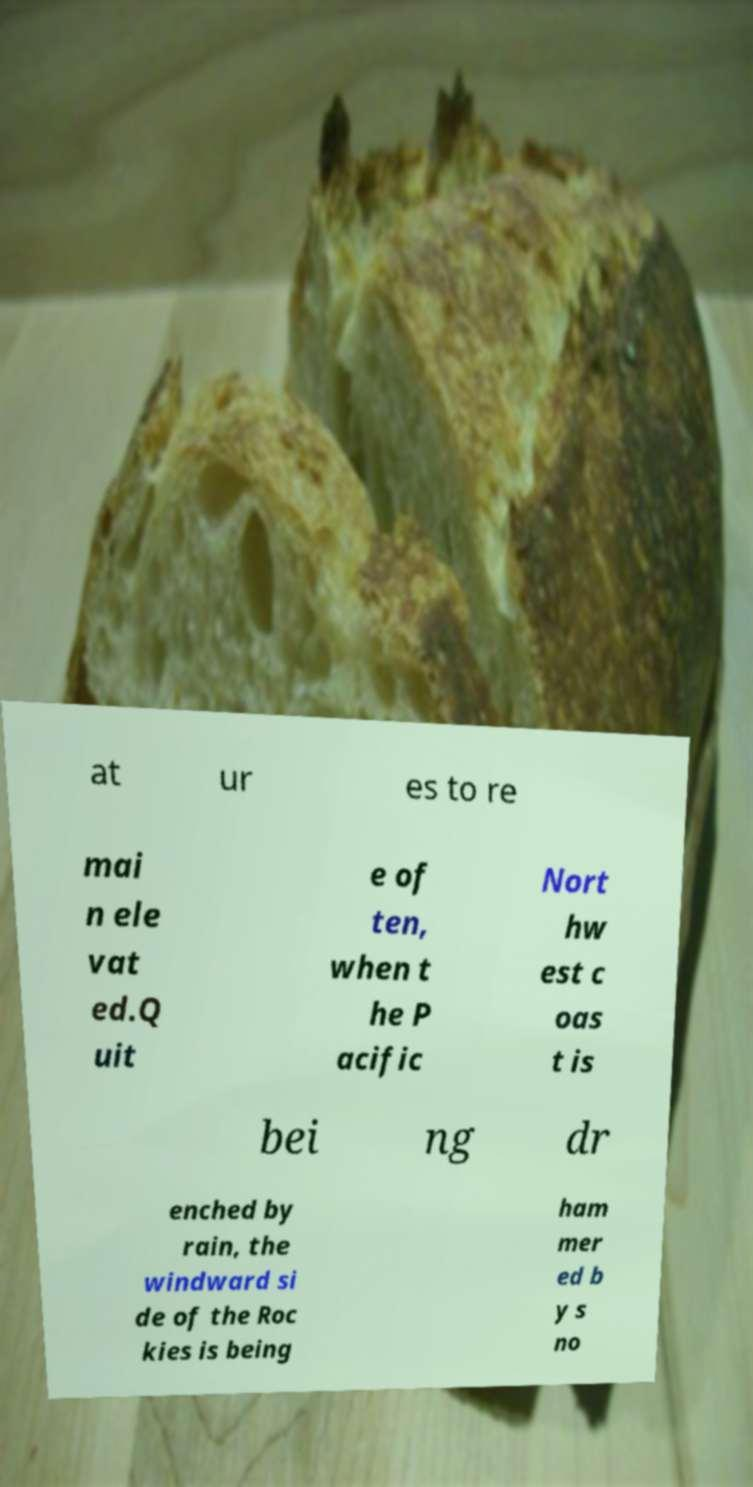Can you read and provide the text displayed in the image?This photo seems to have some interesting text. Can you extract and type it out for me? at ur es to re mai n ele vat ed.Q uit e of ten, when t he P acific Nort hw est c oas t is bei ng dr enched by rain, the windward si de of the Roc kies is being ham mer ed b y s no 